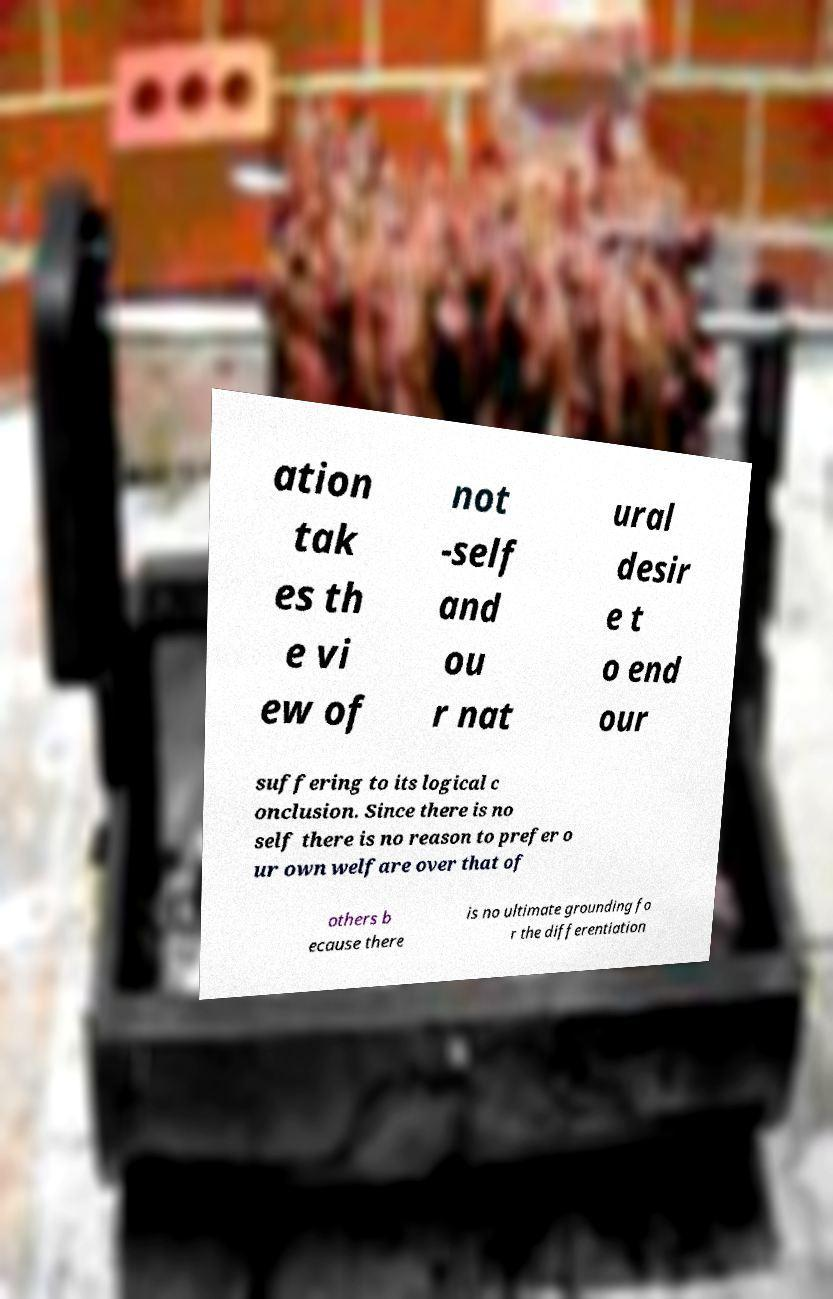I need the written content from this picture converted into text. Can you do that? ation tak es th e vi ew of not -self and ou r nat ural desir e t o end our suffering to its logical c onclusion. Since there is no self there is no reason to prefer o ur own welfare over that of others b ecause there is no ultimate grounding fo r the differentiation 